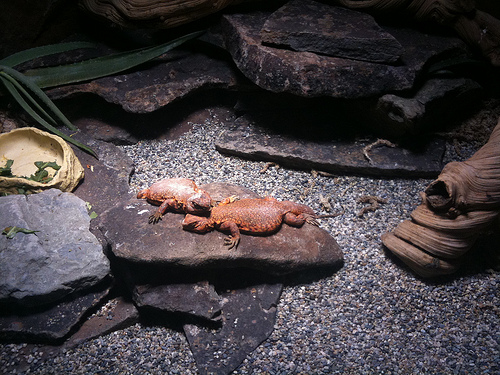<image>
Can you confirm if the lizard is on the gravel? No. The lizard is not positioned on the gravel. They may be near each other, but the lizard is not supported by or resting on top of the gravel. 